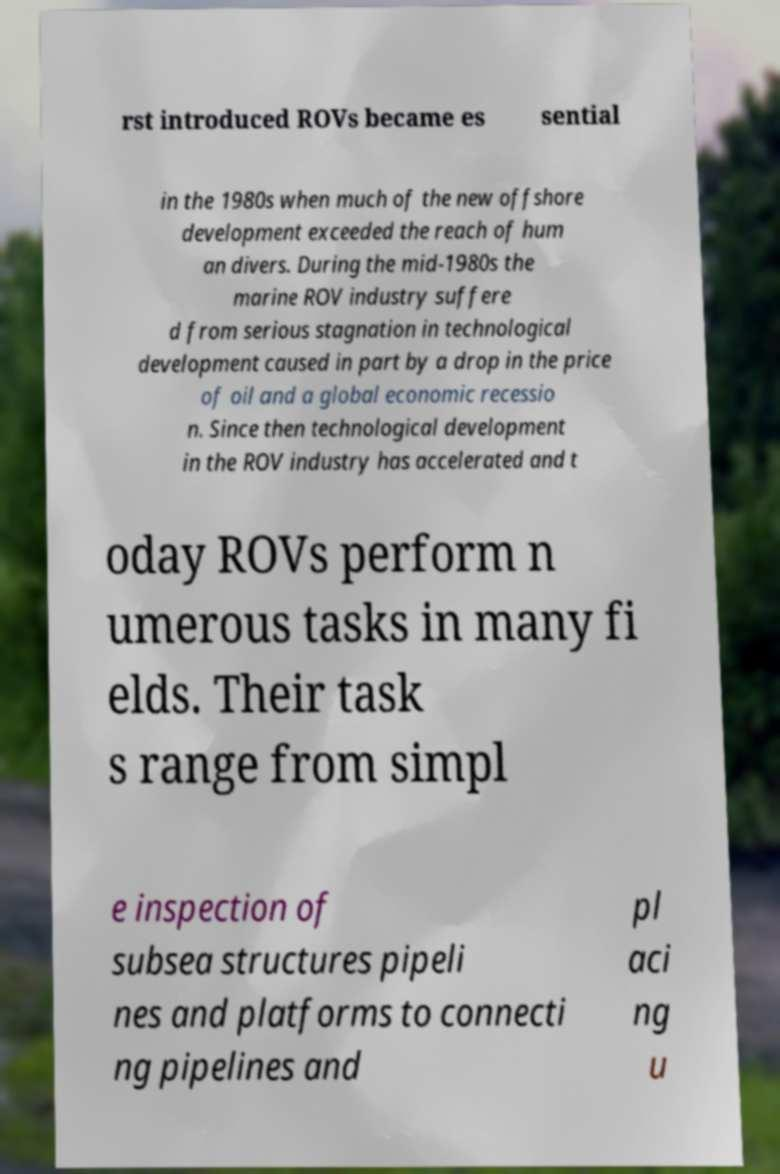I need the written content from this picture converted into text. Can you do that? rst introduced ROVs became es sential in the 1980s when much of the new offshore development exceeded the reach of hum an divers. During the mid-1980s the marine ROV industry suffere d from serious stagnation in technological development caused in part by a drop in the price of oil and a global economic recessio n. Since then technological development in the ROV industry has accelerated and t oday ROVs perform n umerous tasks in many fi elds. Their task s range from simpl e inspection of subsea structures pipeli nes and platforms to connecti ng pipelines and pl aci ng u 